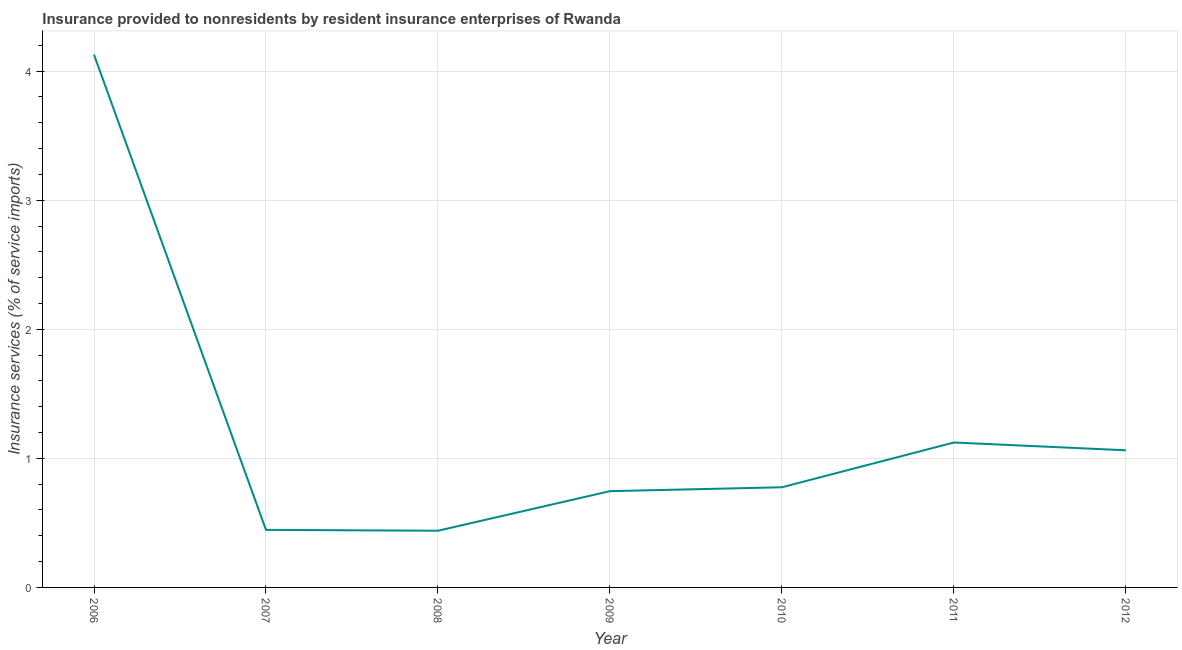What is the insurance and financial services in 2011?
Offer a very short reply. 1.12. Across all years, what is the maximum insurance and financial services?
Your answer should be very brief. 4.13. Across all years, what is the minimum insurance and financial services?
Your answer should be compact. 0.44. In which year was the insurance and financial services maximum?
Ensure brevity in your answer.  2006. In which year was the insurance and financial services minimum?
Keep it short and to the point. 2008. What is the sum of the insurance and financial services?
Give a very brief answer. 8.72. What is the difference between the insurance and financial services in 2006 and 2008?
Provide a short and direct response. 3.69. What is the average insurance and financial services per year?
Your answer should be very brief. 1.25. What is the median insurance and financial services?
Offer a very short reply. 0.78. Do a majority of the years between 2011 and 2007 (inclusive) have insurance and financial services greater than 1.8 %?
Provide a short and direct response. Yes. What is the ratio of the insurance and financial services in 2007 to that in 2012?
Make the answer very short. 0.42. What is the difference between the highest and the second highest insurance and financial services?
Your response must be concise. 3. Is the sum of the insurance and financial services in 2006 and 2012 greater than the maximum insurance and financial services across all years?
Offer a very short reply. Yes. What is the difference between the highest and the lowest insurance and financial services?
Provide a short and direct response. 3.69. How many lines are there?
Make the answer very short. 1. How many years are there in the graph?
Give a very brief answer. 7. Does the graph contain any zero values?
Your answer should be compact. No. What is the title of the graph?
Give a very brief answer. Insurance provided to nonresidents by resident insurance enterprises of Rwanda. What is the label or title of the X-axis?
Give a very brief answer. Year. What is the label or title of the Y-axis?
Provide a short and direct response. Insurance services (% of service imports). What is the Insurance services (% of service imports) in 2006?
Keep it short and to the point. 4.13. What is the Insurance services (% of service imports) in 2007?
Provide a succinct answer. 0.45. What is the Insurance services (% of service imports) of 2008?
Offer a very short reply. 0.44. What is the Insurance services (% of service imports) in 2009?
Ensure brevity in your answer.  0.75. What is the Insurance services (% of service imports) of 2010?
Give a very brief answer. 0.78. What is the Insurance services (% of service imports) of 2011?
Your answer should be very brief. 1.12. What is the Insurance services (% of service imports) in 2012?
Give a very brief answer. 1.06. What is the difference between the Insurance services (% of service imports) in 2006 and 2007?
Offer a very short reply. 3.68. What is the difference between the Insurance services (% of service imports) in 2006 and 2008?
Offer a terse response. 3.69. What is the difference between the Insurance services (% of service imports) in 2006 and 2009?
Provide a succinct answer. 3.38. What is the difference between the Insurance services (% of service imports) in 2006 and 2010?
Your answer should be compact. 3.35. What is the difference between the Insurance services (% of service imports) in 2006 and 2011?
Offer a very short reply. 3. What is the difference between the Insurance services (% of service imports) in 2006 and 2012?
Your answer should be very brief. 3.07. What is the difference between the Insurance services (% of service imports) in 2007 and 2008?
Offer a terse response. 0.01. What is the difference between the Insurance services (% of service imports) in 2007 and 2009?
Offer a very short reply. -0.3. What is the difference between the Insurance services (% of service imports) in 2007 and 2010?
Provide a succinct answer. -0.33. What is the difference between the Insurance services (% of service imports) in 2007 and 2011?
Your answer should be compact. -0.68. What is the difference between the Insurance services (% of service imports) in 2007 and 2012?
Offer a terse response. -0.62. What is the difference between the Insurance services (% of service imports) in 2008 and 2009?
Give a very brief answer. -0.31. What is the difference between the Insurance services (% of service imports) in 2008 and 2010?
Make the answer very short. -0.34. What is the difference between the Insurance services (% of service imports) in 2008 and 2011?
Keep it short and to the point. -0.68. What is the difference between the Insurance services (% of service imports) in 2008 and 2012?
Your answer should be compact. -0.62. What is the difference between the Insurance services (% of service imports) in 2009 and 2010?
Offer a terse response. -0.03. What is the difference between the Insurance services (% of service imports) in 2009 and 2011?
Give a very brief answer. -0.38. What is the difference between the Insurance services (% of service imports) in 2009 and 2012?
Make the answer very short. -0.32. What is the difference between the Insurance services (% of service imports) in 2010 and 2011?
Your answer should be compact. -0.35. What is the difference between the Insurance services (% of service imports) in 2010 and 2012?
Your answer should be very brief. -0.29. What is the difference between the Insurance services (% of service imports) in 2011 and 2012?
Your answer should be compact. 0.06. What is the ratio of the Insurance services (% of service imports) in 2006 to that in 2007?
Ensure brevity in your answer.  9.26. What is the ratio of the Insurance services (% of service imports) in 2006 to that in 2008?
Offer a very short reply. 9.4. What is the ratio of the Insurance services (% of service imports) in 2006 to that in 2009?
Your answer should be compact. 5.53. What is the ratio of the Insurance services (% of service imports) in 2006 to that in 2010?
Ensure brevity in your answer.  5.32. What is the ratio of the Insurance services (% of service imports) in 2006 to that in 2011?
Your answer should be very brief. 3.68. What is the ratio of the Insurance services (% of service imports) in 2006 to that in 2012?
Keep it short and to the point. 3.88. What is the ratio of the Insurance services (% of service imports) in 2007 to that in 2009?
Give a very brief answer. 0.6. What is the ratio of the Insurance services (% of service imports) in 2007 to that in 2010?
Give a very brief answer. 0.57. What is the ratio of the Insurance services (% of service imports) in 2007 to that in 2011?
Provide a short and direct response. 0.4. What is the ratio of the Insurance services (% of service imports) in 2007 to that in 2012?
Offer a terse response. 0.42. What is the ratio of the Insurance services (% of service imports) in 2008 to that in 2009?
Keep it short and to the point. 0.59. What is the ratio of the Insurance services (% of service imports) in 2008 to that in 2010?
Make the answer very short. 0.57. What is the ratio of the Insurance services (% of service imports) in 2008 to that in 2011?
Provide a short and direct response. 0.39. What is the ratio of the Insurance services (% of service imports) in 2008 to that in 2012?
Make the answer very short. 0.41. What is the ratio of the Insurance services (% of service imports) in 2009 to that in 2010?
Offer a terse response. 0.96. What is the ratio of the Insurance services (% of service imports) in 2009 to that in 2011?
Give a very brief answer. 0.66. What is the ratio of the Insurance services (% of service imports) in 2009 to that in 2012?
Offer a terse response. 0.7. What is the ratio of the Insurance services (% of service imports) in 2010 to that in 2011?
Your response must be concise. 0.69. What is the ratio of the Insurance services (% of service imports) in 2010 to that in 2012?
Your answer should be very brief. 0.73. What is the ratio of the Insurance services (% of service imports) in 2011 to that in 2012?
Ensure brevity in your answer.  1.06. 